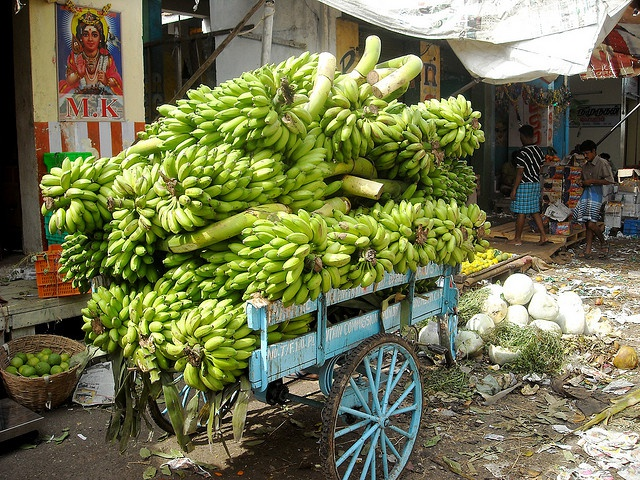Describe the objects in this image and their specific colors. I can see banana in black, darkgreen, and olive tones, banana in black, olive, darkgreen, and khaki tones, banana in black, olive, darkgreen, and khaki tones, banana in black, olive, darkgreen, and khaki tones, and banana in black, olive, darkgreen, and khaki tones in this image. 